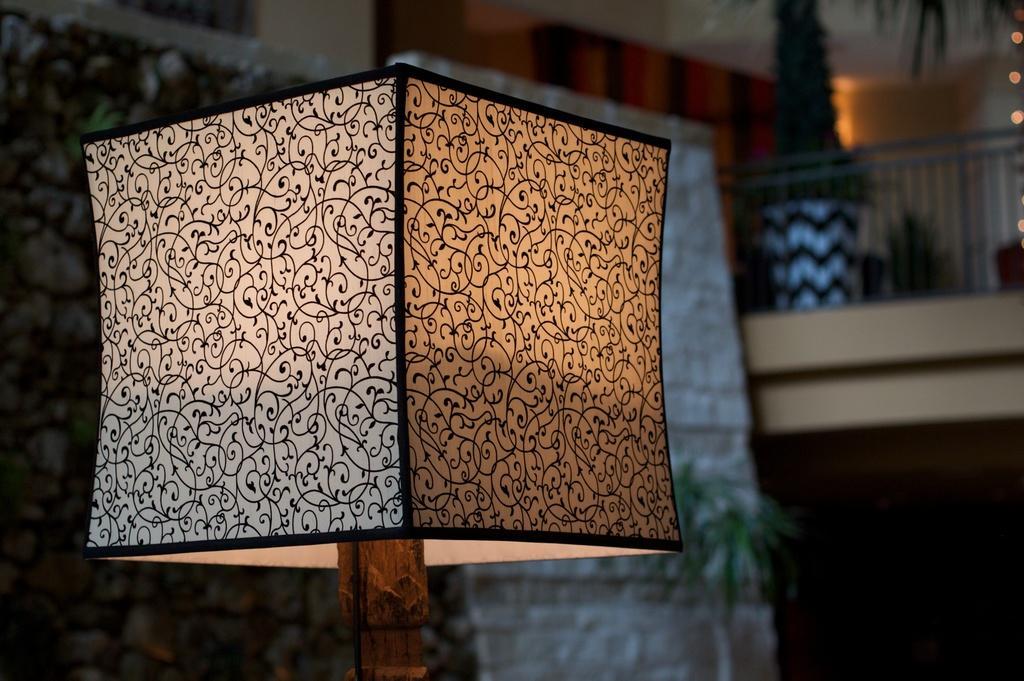How would you summarize this image in a sentence or two? In this image we can see a lamp and the background is blurry with plant and fence. 